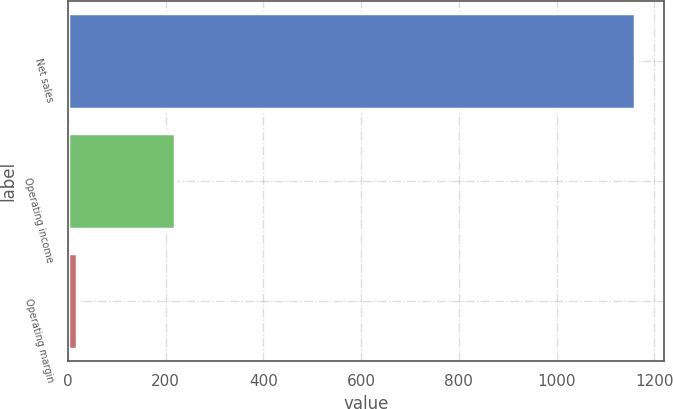Convert chart to OTSL. <chart><loc_0><loc_0><loc_500><loc_500><bar_chart><fcel>Net sales<fcel>Operating income<fcel>Operating margin<nl><fcel>1161<fcel>219<fcel>18.9<nl></chart> 